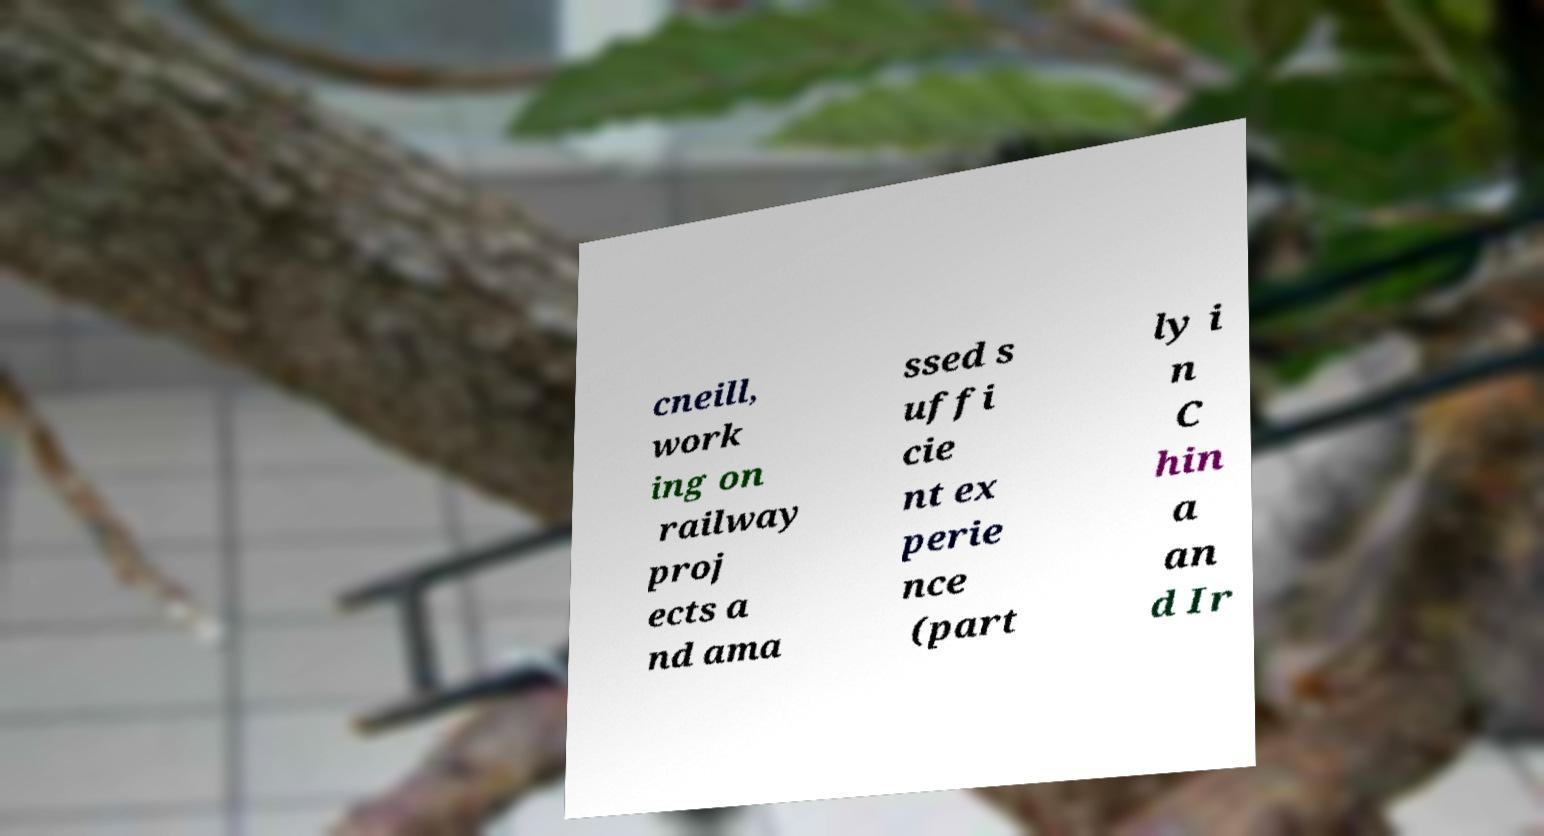Could you assist in decoding the text presented in this image and type it out clearly? cneill, work ing on railway proj ects a nd ama ssed s uffi cie nt ex perie nce (part ly i n C hin a an d Ir 